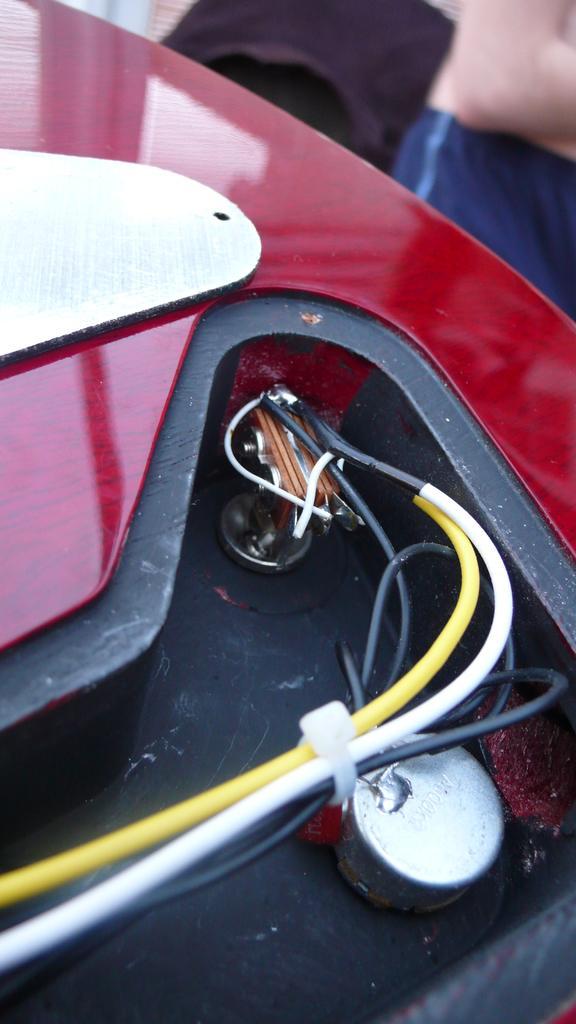Describe this image in one or two sentences. In this picture I can see a red and white color thing in front and I can see the wires. 